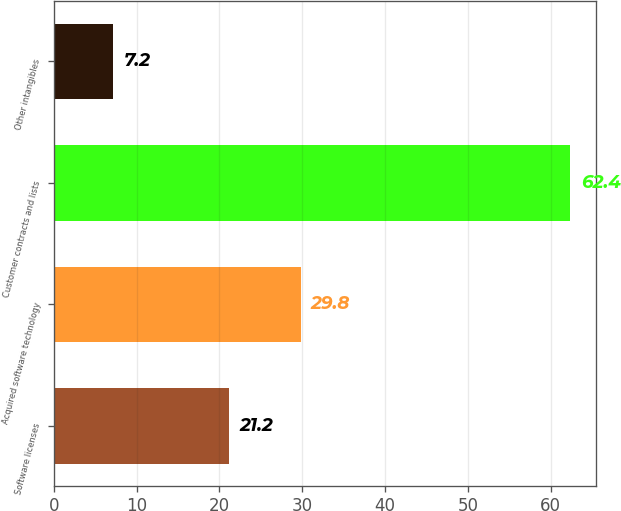Convert chart. <chart><loc_0><loc_0><loc_500><loc_500><bar_chart><fcel>Software licenses<fcel>Acquired software technology<fcel>Customer contracts and lists<fcel>Other intangibles<nl><fcel>21.2<fcel>29.8<fcel>62.4<fcel>7.2<nl></chart> 